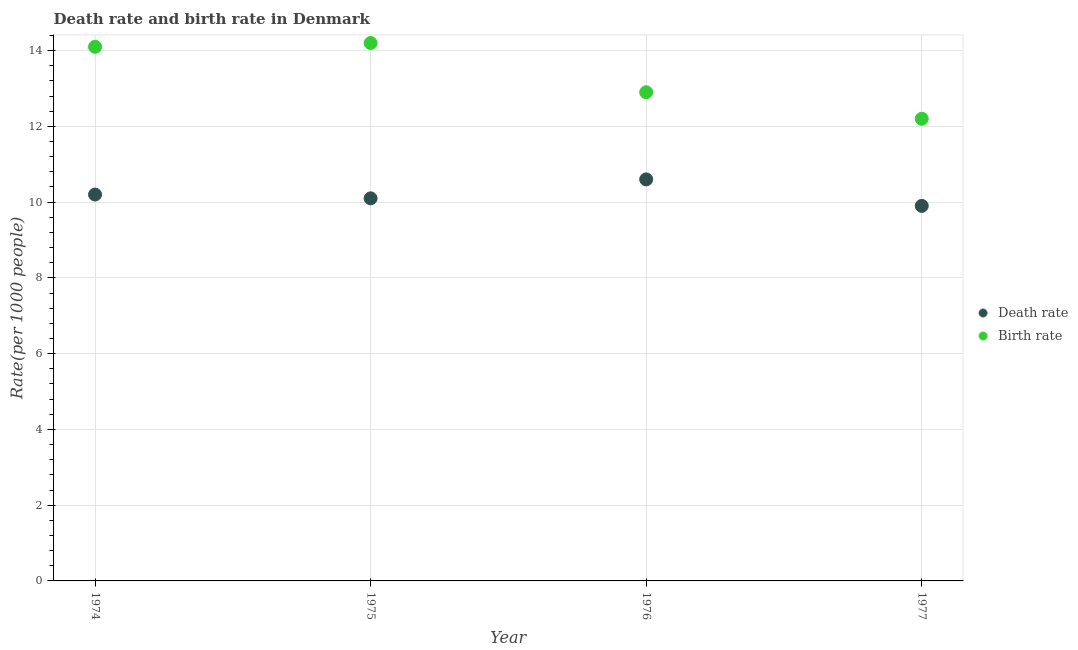How many different coloured dotlines are there?
Offer a very short reply. 2. What is the death rate in 1975?
Your answer should be compact. 10.1. Across all years, what is the maximum birth rate?
Make the answer very short. 14.2. Across all years, what is the minimum birth rate?
Make the answer very short. 12.2. In which year was the death rate maximum?
Your answer should be very brief. 1976. What is the total death rate in the graph?
Your answer should be compact. 40.8. What is the difference between the birth rate in 1974 and that in 1977?
Your answer should be very brief. 1.9. What is the average death rate per year?
Give a very brief answer. 10.2. In how many years, is the birth rate greater than 13.6?
Provide a succinct answer. 2. What is the ratio of the birth rate in 1974 to that in 1976?
Your answer should be very brief. 1.09. Is the birth rate in 1974 less than that in 1975?
Your answer should be very brief. Yes. Is the difference between the death rate in 1975 and 1977 greater than the difference between the birth rate in 1975 and 1977?
Provide a succinct answer. No. What is the difference between the highest and the second highest death rate?
Make the answer very short. 0.4. What is the difference between the highest and the lowest death rate?
Give a very brief answer. 0.7. Is the sum of the birth rate in 1976 and 1977 greater than the maximum death rate across all years?
Keep it short and to the point. Yes. Does the birth rate monotonically increase over the years?
Offer a terse response. No. Is the birth rate strictly less than the death rate over the years?
Offer a very short reply. No. How many years are there in the graph?
Your answer should be very brief. 4. What is the difference between two consecutive major ticks on the Y-axis?
Keep it short and to the point. 2. Where does the legend appear in the graph?
Your response must be concise. Center right. How many legend labels are there?
Offer a very short reply. 2. How are the legend labels stacked?
Offer a terse response. Vertical. What is the title of the graph?
Your response must be concise. Death rate and birth rate in Denmark. What is the label or title of the Y-axis?
Provide a short and direct response. Rate(per 1000 people). What is the Rate(per 1000 people) of Death rate in 1974?
Give a very brief answer. 10.2. What is the Rate(per 1000 people) in Death rate in 1975?
Your answer should be compact. 10.1. What is the Rate(per 1000 people) of Birth rate in 1975?
Your response must be concise. 14.2. What is the Rate(per 1000 people) of Death rate in 1977?
Make the answer very short. 9.9. What is the Rate(per 1000 people) of Birth rate in 1977?
Keep it short and to the point. 12.2. Across all years, what is the maximum Rate(per 1000 people) in Death rate?
Your answer should be compact. 10.6. Across all years, what is the minimum Rate(per 1000 people) of Birth rate?
Keep it short and to the point. 12.2. What is the total Rate(per 1000 people) of Death rate in the graph?
Your response must be concise. 40.8. What is the total Rate(per 1000 people) in Birth rate in the graph?
Your answer should be compact. 53.4. What is the difference between the Rate(per 1000 people) in Birth rate in 1974 and that in 1976?
Make the answer very short. 1.2. What is the difference between the Rate(per 1000 people) in Death rate in 1974 and that in 1977?
Make the answer very short. 0.3. What is the difference between the Rate(per 1000 people) of Birth rate in 1974 and that in 1977?
Ensure brevity in your answer.  1.9. What is the difference between the Rate(per 1000 people) in Death rate in 1975 and that in 1976?
Provide a succinct answer. -0.5. What is the difference between the Rate(per 1000 people) in Death rate in 1974 and the Rate(per 1000 people) in Birth rate in 1975?
Your response must be concise. -4. What is the difference between the Rate(per 1000 people) in Death rate in 1974 and the Rate(per 1000 people) in Birth rate in 1976?
Ensure brevity in your answer.  -2.7. What is the difference between the Rate(per 1000 people) in Death rate in 1974 and the Rate(per 1000 people) in Birth rate in 1977?
Provide a short and direct response. -2. What is the difference between the Rate(per 1000 people) in Death rate in 1975 and the Rate(per 1000 people) in Birth rate in 1976?
Give a very brief answer. -2.8. What is the difference between the Rate(per 1000 people) in Death rate in 1976 and the Rate(per 1000 people) in Birth rate in 1977?
Your answer should be compact. -1.6. What is the average Rate(per 1000 people) of Death rate per year?
Make the answer very short. 10.2. What is the average Rate(per 1000 people) of Birth rate per year?
Keep it short and to the point. 13.35. What is the ratio of the Rate(per 1000 people) of Death rate in 1974 to that in 1975?
Give a very brief answer. 1.01. What is the ratio of the Rate(per 1000 people) of Death rate in 1974 to that in 1976?
Your answer should be very brief. 0.96. What is the ratio of the Rate(per 1000 people) of Birth rate in 1974 to that in 1976?
Make the answer very short. 1.09. What is the ratio of the Rate(per 1000 people) in Death rate in 1974 to that in 1977?
Give a very brief answer. 1.03. What is the ratio of the Rate(per 1000 people) in Birth rate in 1974 to that in 1977?
Offer a very short reply. 1.16. What is the ratio of the Rate(per 1000 people) of Death rate in 1975 to that in 1976?
Your answer should be very brief. 0.95. What is the ratio of the Rate(per 1000 people) of Birth rate in 1975 to that in 1976?
Your answer should be compact. 1.1. What is the ratio of the Rate(per 1000 people) of Death rate in 1975 to that in 1977?
Give a very brief answer. 1.02. What is the ratio of the Rate(per 1000 people) in Birth rate in 1975 to that in 1977?
Keep it short and to the point. 1.16. What is the ratio of the Rate(per 1000 people) of Death rate in 1976 to that in 1977?
Make the answer very short. 1.07. What is the ratio of the Rate(per 1000 people) in Birth rate in 1976 to that in 1977?
Give a very brief answer. 1.06. What is the difference between the highest and the second highest Rate(per 1000 people) in Death rate?
Offer a very short reply. 0.4. What is the difference between the highest and the second highest Rate(per 1000 people) of Birth rate?
Give a very brief answer. 0.1. 